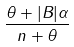Convert formula to latex. <formula><loc_0><loc_0><loc_500><loc_500>\frac { \theta + | B | \alpha } { n + \theta }</formula> 